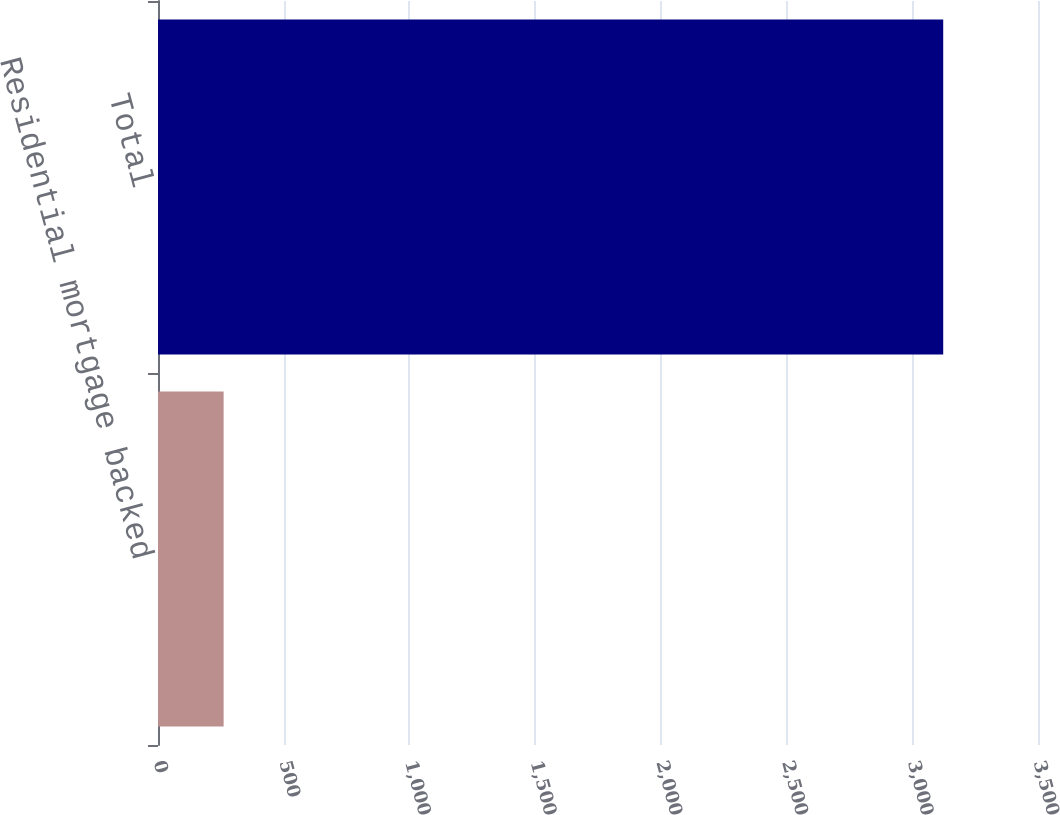Convert chart. <chart><loc_0><loc_0><loc_500><loc_500><bar_chart><fcel>Residential mortgage backed<fcel>Total<nl><fcel>261<fcel>3123<nl></chart> 